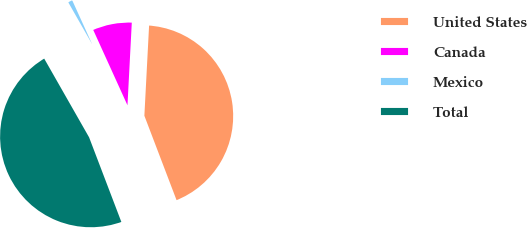Convert chart. <chart><loc_0><loc_0><loc_500><loc_500><pie_chart><fcel>United States<fcel>Canada<fcel>Mexico<fcel>Total<nl><fcel>43.37%<fcel>7.62%<fcel>1.46%<fcel>47.55%<nl></chart> 